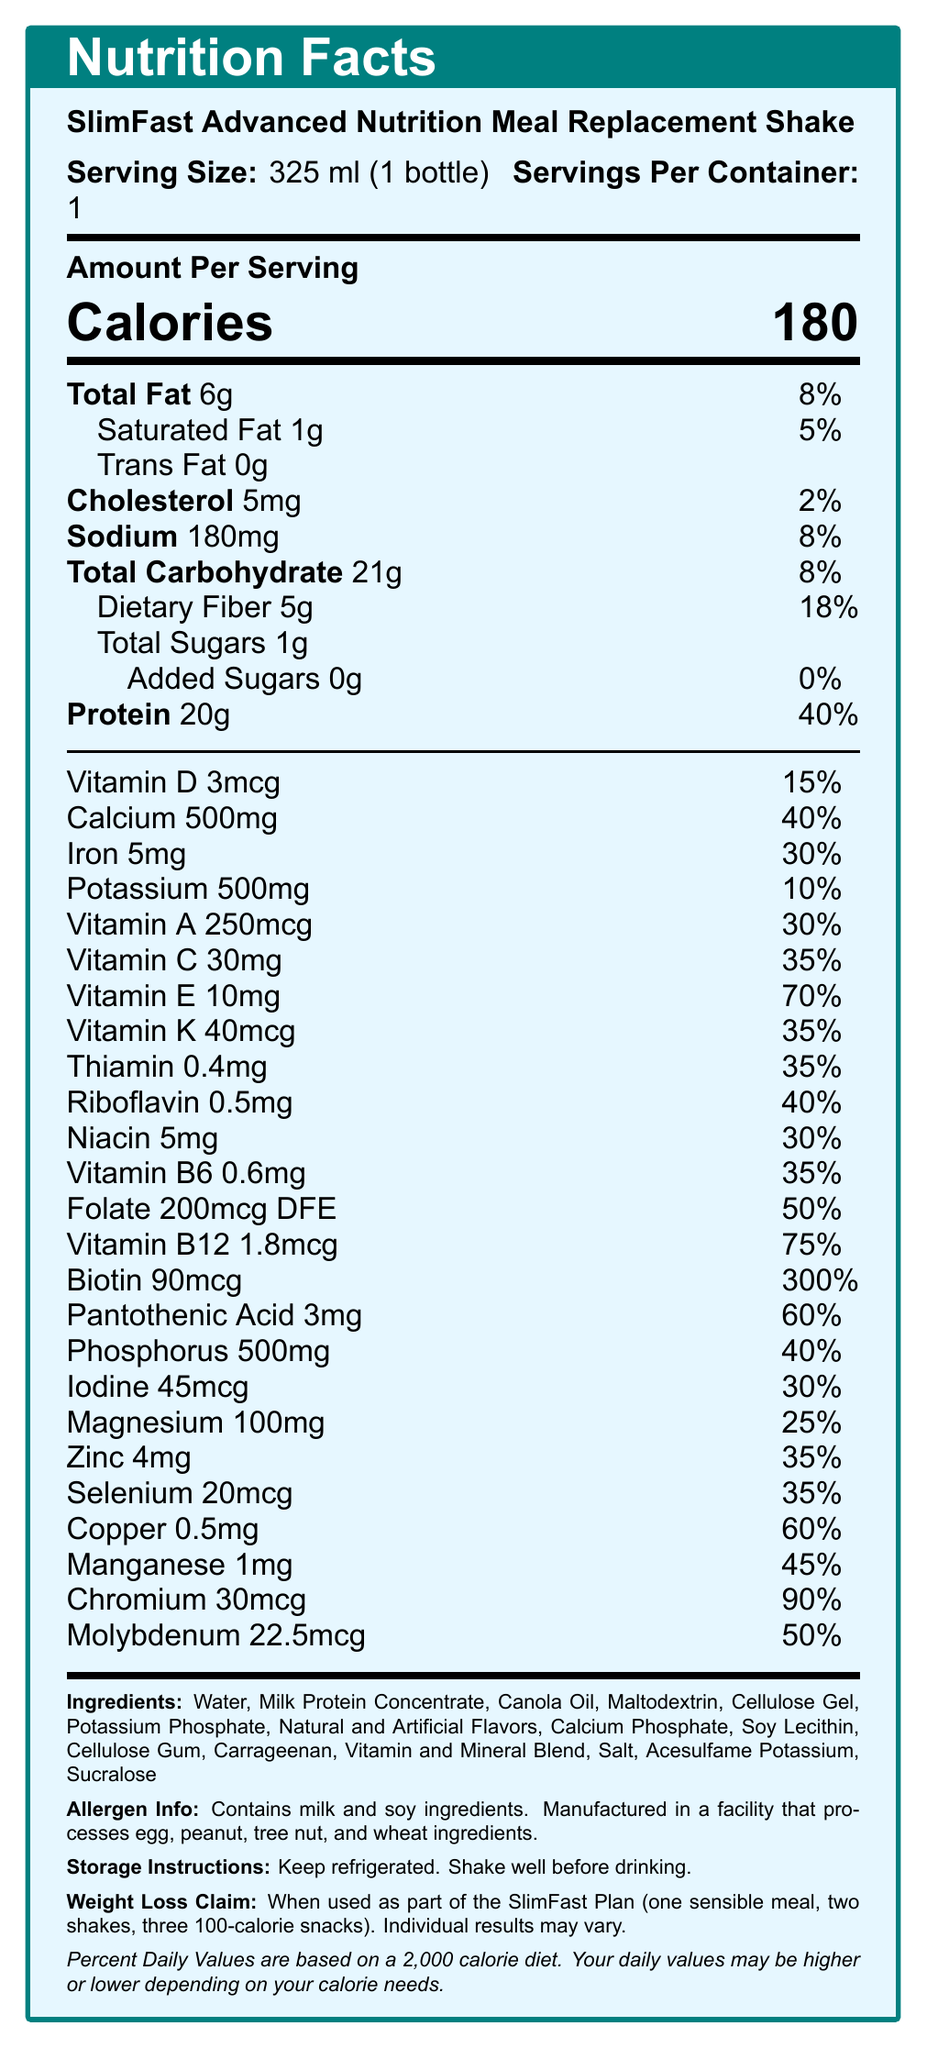what is the serving size? The document states that the serving size is "325 ml (1 bottle)".
Answer: 325 ml (1 bottle) how many calories are in one serving? The document specifically mentions that each serving contains 180 calories.
Answer: 180 how much protein is in one serving and what percentage of the daily value does it represent? The nutritional information shows 20g of protein, which is 40% of the daily value.
Answer: 20g, 40% what is the total carbohydrate content per serving? The document states that the total carbohydrate content is 21g per serving.
Answer: 21g which vitamins and minerals exceed 50% of the daily value? The following amounts exceed 50% of the daily value: Biotin (300%), Vitamin B12 (75%), Pantothenic Acid (60%), Chromium (90%), Molybdenum (50%).
Answer: Biotin, Vitamin B12, Pantothenic Acid, Chromium, Molybdenum which ingredient(s) may cause allergy concerns? The allergen information states that the product contains milk and soy ingredients.
Answer: Milk and Soy ingredients what is the weight loss claim associated with the product? The document states this claim directly in the weight loss claim section.
Answer: When used as part of the SlimFast Plan (one sensible meal, two shakes, three 100-calorie snacks). Individual results may vary. what is the total fat content and how much of it is saturated fat? The document mentions that the total fat content is 6g, with 1g being saturated fat.
Answer: Total Fat: 6g, Saturated Fat: 1g how should the product be stored? The storage instructions provided state to keep the product refrigerated and to shake well before drinking.
Answer: Keep refrigerated. Shake well before drinking. what is the percentage daily value of Vitamin D per serving? A. 10% B. 15% C. 25% D. 30% The nutritional information section lists Vitamin D at 15% daily value.
Answer: B how much calcium is in each serving? A. 300mg B. 400mg C. 500mg D. 600mg The document shows that there is 500mg of calcium per serving.
Answer: C is this product free of trans fat? The document explicitly mentions there is 0g of trans fat.
Answer: Yes what main point does the entire document communicate? The document details the nutritional facts, ingredients, allergen info, storage instructions, weight loss claims, and other relevant details about the meal replacement shake.
Answer: Nutritional breakdown of SlimFast Advanced Nutrition Meal Replacement Shake and related information. how many different vitamins and minerals are listed in the document? The document lists 25 different vitamins and minerals in the nutritional information section.
Answer: 25 what is the carbohydrate breakdown in terms of dietary fiber and sugars? The document details that out of the total 21g carbohydrates, 5g is dietary fiber, and 1g is total sugars with 0g added sugars.
Answer: Dietary Fiber: 5g, Total Sugars: 1g (0g added sugars) can the product be consumed by someone allergic to peanuts? The allergen information states that the product is manufactured in a facility that processes peanuts, but it does not confirm whether peanuts are present in the product itself.
Answer: Cannot be determined 